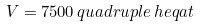<formula> <loc_0><loc_0><loc_500><loc_500>V = 7 5 0 0 \, q u a d r u p l e \, h e q a t</formula> 